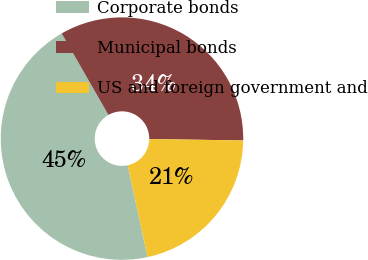<chart> <loc_0><loc_0><loc_500><loc_500><pie_chart><fcel>Corporate bonds<fcel>Municipal bonds<fcel>US and foreign government and<nl><fcel>45.1%<fcel>33.52%<fcel>21.37%<nl></chart> 